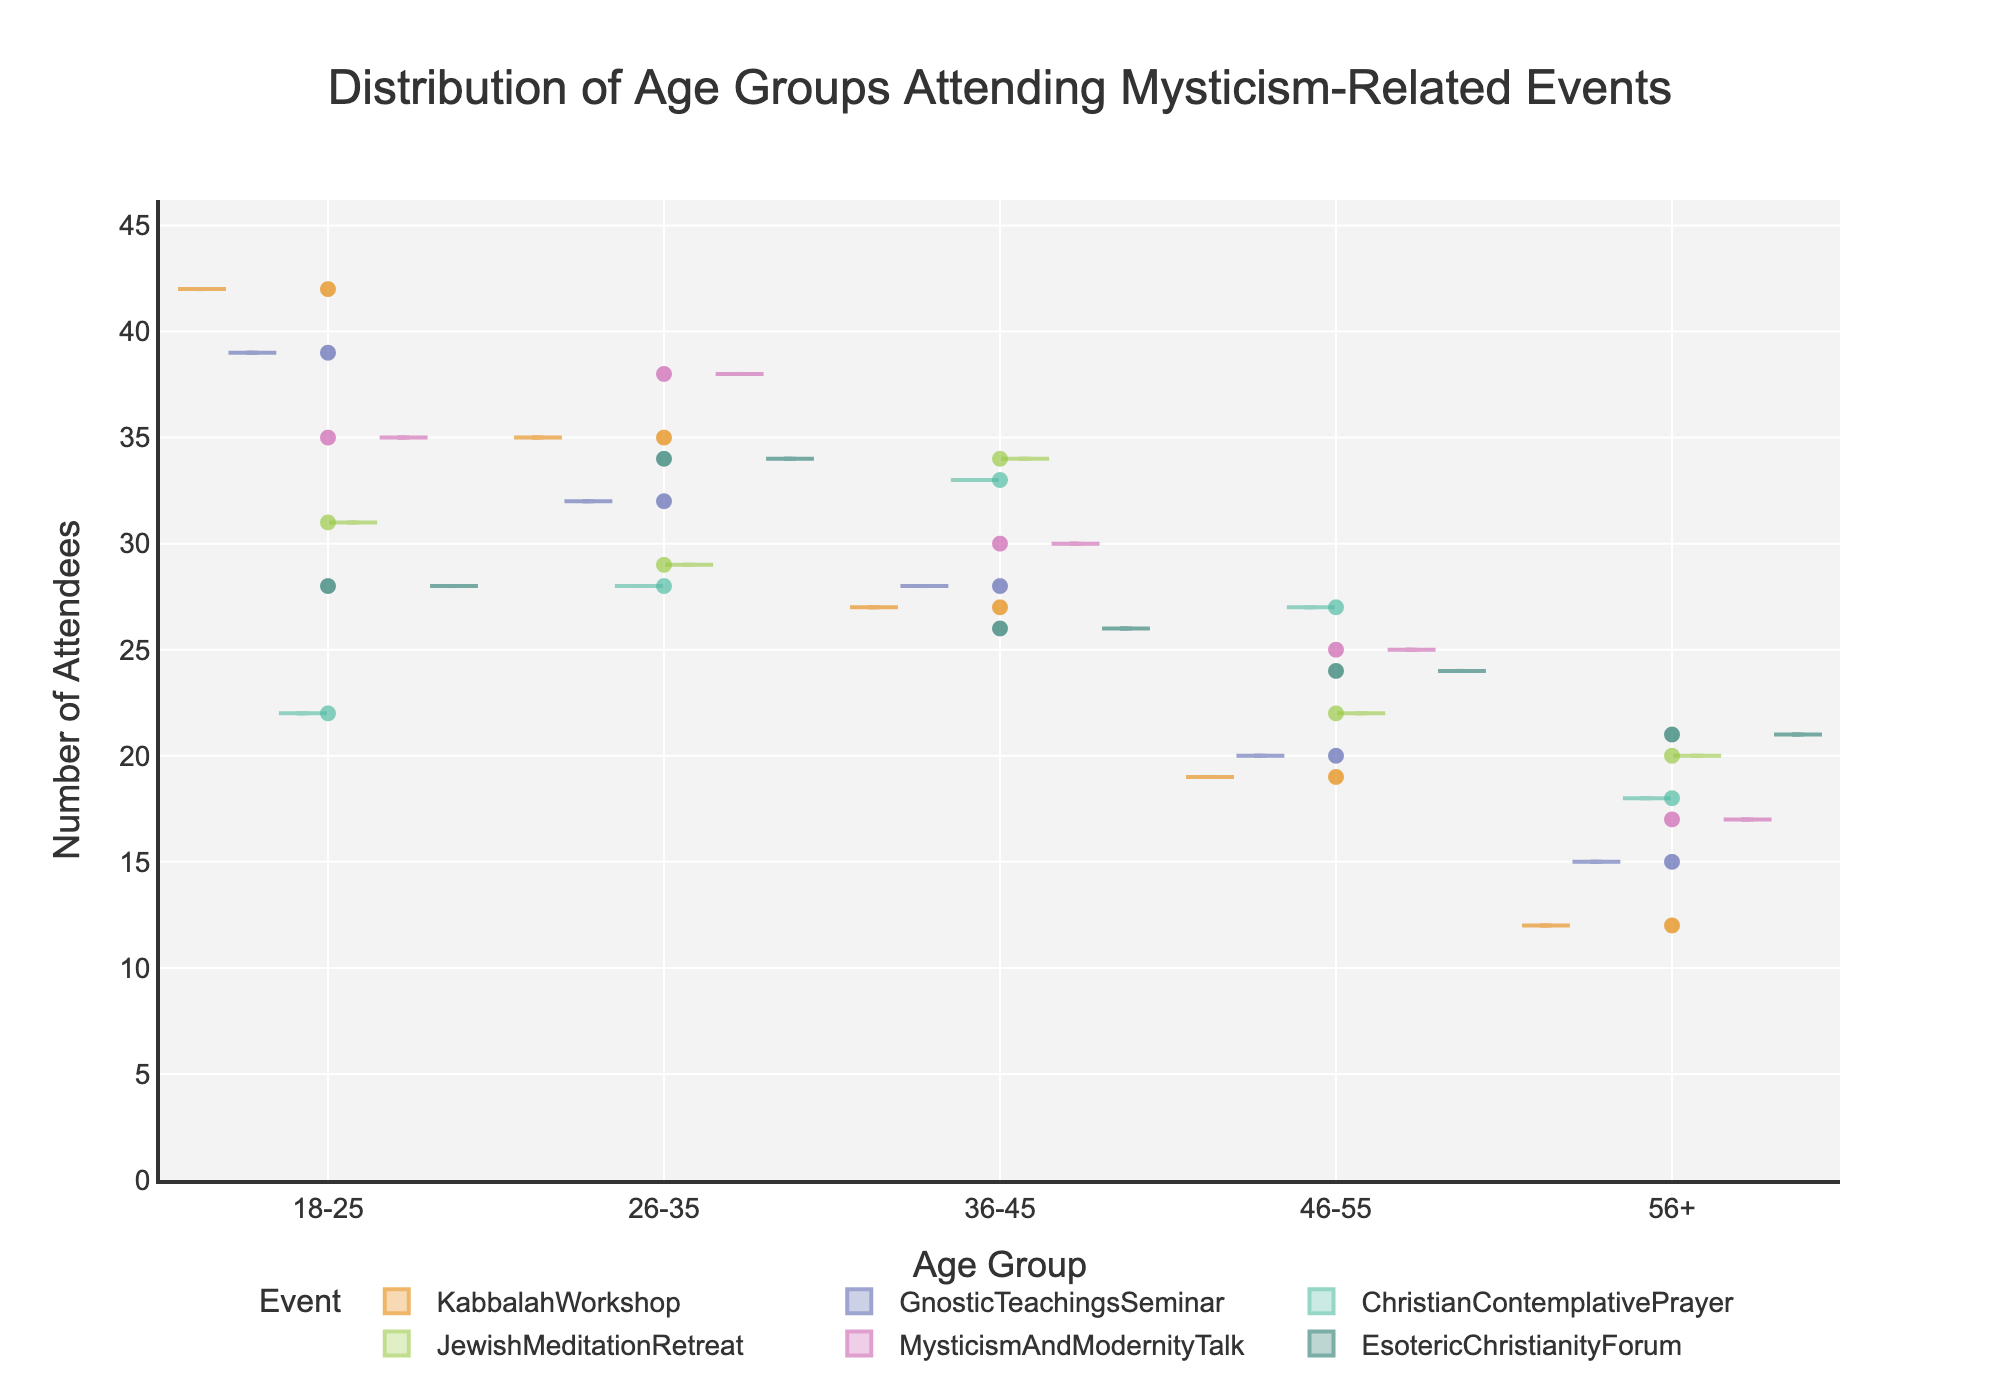What is the title of the figure? The title is usually displayed at the top of the figure in large font. Here, it is written in bold above the plot area.
Answer: Distribution of Age Groups Attending Mysticism-Related Events What does the x-axis represent? The x-axis label is located below the horizontal axis. It specifies what each point along the axis stands for. The label here reads "Age Group."
Answer: Age Group How many age groups are there in the figure? The x-axis should show categories representing different age groups visualized as labels. Count the distinct age groups represented by these labels.
Answer: 5 Which event has the highest number of attendees in the 18-25 age group? Look at the violin plots and jittered points corresponding to the 18-25 age group for each event. Identify the point or section that extends the highest vertically.
Answer: Kabbalah Workshop Which age group has the least attendees across all events? Observe the vertical extent of each violin plot and the distribution of points within them. Find the age group consistently showing lower attendee counts in most events.
Answer: 56+ Compare the number of attendees in the 26-35 age group for 'Christian Contemplative Prayer' and 'Jewish Meditation Retreat'. Which is higher? Examine the point and distribution within the 26-35 category for both events. Identify which one extends higher on the y-axis.
Answer: Christian Contemplative Prayer What's the general trend in the number of attendees as the age group increases across most events? Observe each event's distribution from left (younger age groups) to right (older age groups). Note if there's a common pattern in the violin plots' width and distribution.
Answer: Decreases Which age group has the most balanced attendance across the events? Look for an age group where the number of attendees seems consistent across different events, indicated by similar heights of the violin plots.
Answer: 36-45 In which age group do we see the widest variation in attendees? Look at the breadth of the violin plots for different age groups. The group with the widest plot indicates the most variation.
Answer: 18-25 Which event has the smallest number of attendees in the 56+ age group? Examine the violin plot and points corresponding to the 56+ age group across all events. Identify the event with the lowest vertical extent.
Answer: Kabbalah Workshop 